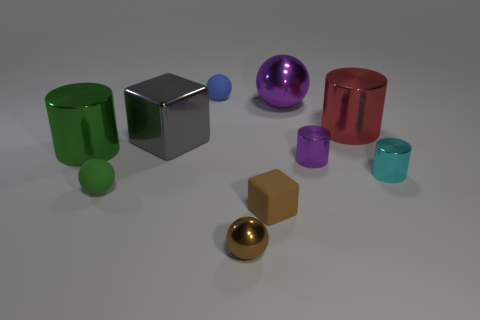Does the tiny matte block have the same color as the tiny metal sphere?
Offer a very short reply. Yes. There is a shiny ball that is in front of the big green metallic thing; is its color the same as the cube that is right of the small brown metallic ball?
Your answer should be compact. Yes. What number of tiny metal things are the same color as the large metallic sphere?
Keep it short and to the point. 1. What is the small sphere that is behind the large thing that is on the right side of the purple thing that is on the left side of the small purple metal object made of?
Provide a short and direct response. Rubber. Is the color of the tiny object in front of the small brown block the same as the small cube?
Keep it short and to the point. Yes. How many brown objects are either metal cubes or big metallic cylinders?
Give a very brief answer. 0. How many other objects are the same shape as the small cyan thing?
Offer a very short reply. 3. Does the green ball have the same material as the green cylinder?
Provide a succinct answer. No. There is a small object that is to the left of the small cube and in front of the small green matte sphere; what material is it made of?
Provide a short and direct response. Metal. There is a shiny cylinder left of the brown metallic thing; what is its color?
Your response must be concise. Green. 